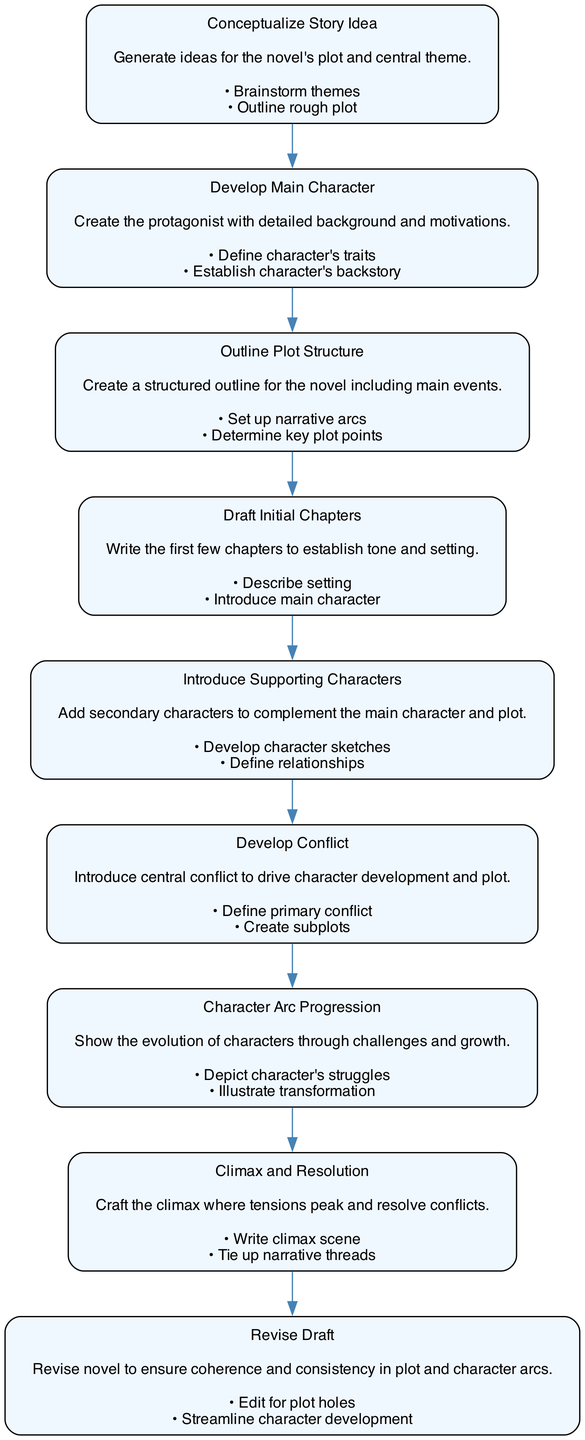What is the first activity in the diagram? The first activity, according to the flow of the diagram, is "Conceptualize Story Idea". This is the starting point from which all other activities branch out.
Answer: Conceptualize Story Idea How many total activities are represented in the diagram? By counting the distinct nodes listed in the activities section of the diagram, we find that there are a total of nine activities.
Answer: 9 What is the last activity in the flow? The last activity is "Revise Draft", which is the concluding step after the climax and resolution have been completed, indicating completion of the writing process.
Answer: Revise Draft Which activity follows "Develop Conflict"? The activity that directly follows "Develop Conflict" in the sequence of transitions is "Character Arc Progression". This shows the progression from presenting conflict to character development.
Answer: Character Arc Progression What are the actions involved in "Draft Initial Chapters"? The actions listed for "Draft Initial Chapters" include "Describe setting" and "Introduce main character", which are essential elements in establishing the beginning of the novel.
Answer: Describe setting, Introduce main character Which two activities are interconnected through transitions? "Outline Plot Structure" and "Draft Initial Chapters" are interconnected through a transition, indicating that after outlining the plot, the next step is to draft the early chapters.
Answer: Outline Plot Structure, Draft Initial Chapters What activity leads to "Climax and Resolution"? The activity that leads directly to "Climax and Resolution" is "Character Arc Progression". This progression emphasizes the character's development leading up to the climax.
Answer: Character Arc Progression How many transitions are present in the diagram? When counting the transitions provided in the diagram, we see there are a total of eight transitions linking the activities together.
Answer: 8 What is the main purpose of the "Character Arc Progression" activity? The main purpose of "Character Arc Progression" is to depict the character's struggles and illustrate their transformation, reflecting their growth throughout the story.
Answer: Depict character's struggles, Illustrate transformation 